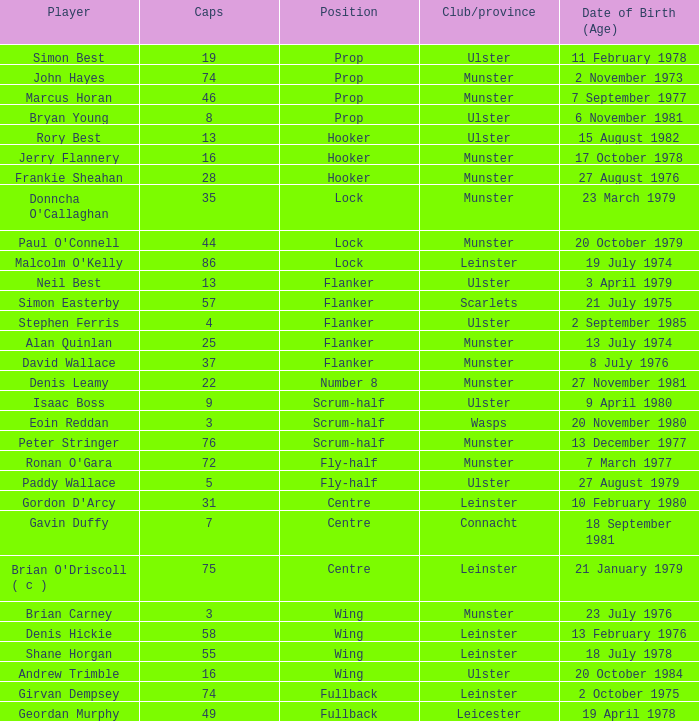Which Ulster player has fewer than 49 caps and plays the wing position? Andrew Trimble. Would you mind parsing the complete table? {'header': ['Player', 'Caps', 'Position', 'Club/province', 'Date of Birth (Age)'], 'rows': [['Simon Best', '19', 'Prop', 'Ulster', '11 February 1978'], ['John Hayes', '74', 'Prop', 'Munster', '2 November 1973'], ['Marcus Horan', '46', 'Prop', 'Munster', '7 September 1977'], ['Bryan Young', '8', 'Prop', 'Ulster', '6 November 1981'], ['Rory Best', '13', 'Hooker', 'Ulster', '15 August 1982'], ['Jerry Flannery', '16', 'Hooker', 'Munster', '17 October 1978'], ['Frankie Sheahan', '28', 'Hooker', 'Munster', '27 August 1976'], ["Donncha O'Callaghan", '35', 'Lock', 'Munster', '23 March 1979'], ["Paul O'Connell", '44', 'Lock', 'Munster', '20 October 1979'], ["Malcolm O'Kelly", '86', 'Lock', 'Leinster', '19 July 1974'], ['Neil Best', '13', 'Flanker', 'Ulster', '3 April 1979'], ['Simon Easterby', '57', 'Flanker', 'Scarlets', '21 July 1975'], ['Stephen Ferris', '4', 'Flanker', 'Ulster', '2 September 1985'], ['Alan Quinlan', '25', 'Flanker', 'Munster', '13 July 1974'], ['David Wallace', '37', 'Flanker', 'Munster', '8 July 1976'], ['Denis Leamy', '22', 'Number 8', 'Munster', '27 November 1981'], ['Isaac Boss', '9', 'Scrum-half', 'Ulster', '9 April 1980'], ['Eoin Reddan', '3', 'Scrum-half', 'Wasps', '20 November 1980'], ['Peter Stringer', '76', 'Scrum-half', 'Munster', '13 December 1977'], ["Ronan O'Gara", '72', 'Fly-half', 'Munster', '7 March 1977'], ['Paddy Wallace', '5', 'Fly-half', 'Ulster', '27 August 1979'], ["Gordon D'Arcy", '31', 'Centre', 'Leinster', '10 February 1980'], ['Gavin Duffy', '7', 'Centre', 'Connacht', '18 September 1981'], ["Brian O'Driscoll ( c )", '75', 'Centre', 'Leinster', '21 January 1979'], ['Brian Carney', '3', 'Wing', 'Munster', '23 July 1976'], ['Denis Hickie', '58', 'Wing', 'Leinster', '13 February 1976'], ['Shane Horgan', '55', 'Wing', 'Leinster', '18 July 1978'], ['Andrew Trimble', '16', 'Wing', 'Ulster', '20 October 1984'], ['Girvan Dempsey', '74', 'Fullback', 'Leinster', '2 October 1975'], ['Geordan Murphy', '49', 'Fullback', 'Leicester', '19 April 1978']]} 